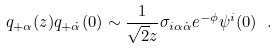Convert formula to latex. <formula><loc_0><loc_0><loc_500><loc_500>q _ { + \alpha } ( z ) q _ { + \dot { \alpha } } ( 0 ) \sim \frac { 1 } { \sqrt { 2 } z } \sigma _ { i \alpha \dot { \alpha } } e ^ { - \phi } \psi ^ { i } ( 0 ) \ .</formula> 